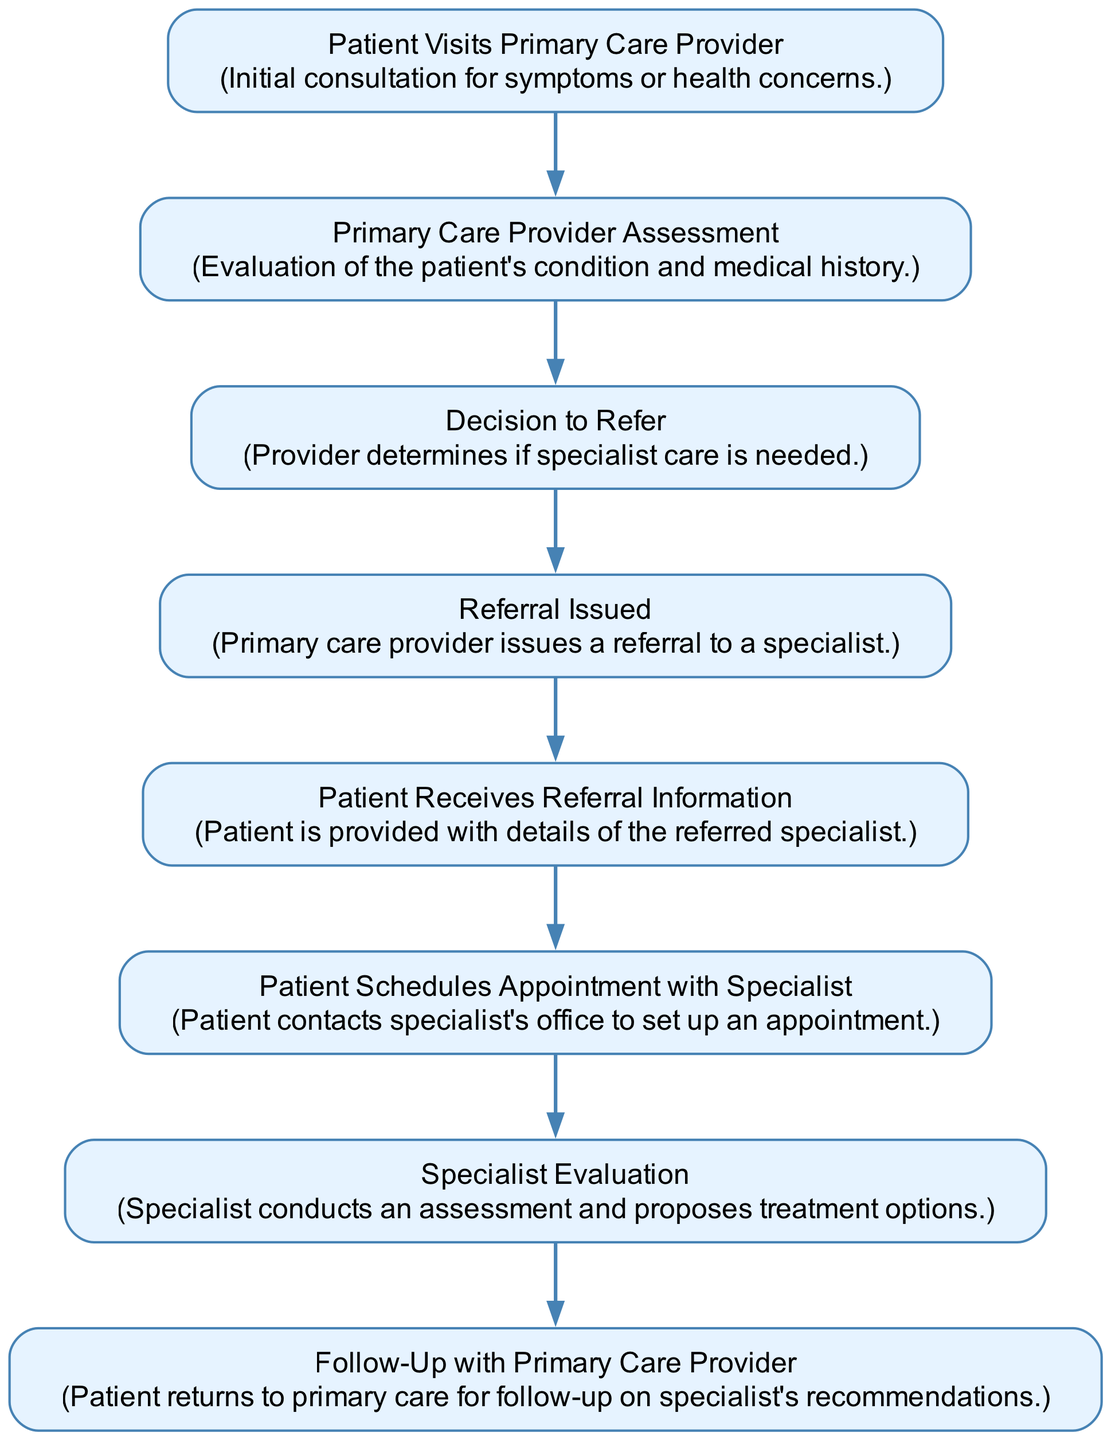What is the first step in the referral process? The first step, as indicated in the diagram, is "Patient Visits Primary Care Provider." This is the initial action taken in the referral process.
Answer: Patient Visits Primary Care Provider How many total steps are in the referral process? By counting each unique element in the diagram, we find there are eight distinct steps in the referral process. This includes every node from the patient's visit to the follow-up.
Answer: 8 What is the step that follows "Referral Issued"? The step that follows "Referral Issued" is "Patient Receives Referral Information." This is connected directly in the flow, showing the next action taken after the referral is issued.
Answer: Patient Receives Referral Information Which step requires the patient to contact the specialist's office? The step where the patient contacts the specialist's office is "Patient Schedules Appointment with Specialist." This indicates that the patient is actively taking action to arrange the appointment.
Answer: Patient Schedules Appointment with Specialist What is the last step in the referral process? The last step in the referral process is "Follow-Up with Primary Care Provider." This indicates that after the specialist's assessment, the patient goes back to the primary care provider for follow-up.
Answer: Follow-Up with Primary Care Provider What happens after "Specialist Evaluation"? After "Specialist Evaluation," the next step is "Follow-Up with Primary Care Provider." This shows the structure of the process where the outcomes of the specialist's evaluation lead back to the primary care provider.
Answer: Follow-Up with Primary Care Provider Which step involves assessment and treatment options? The step involving assessment and treatment options is "Specialist Evaluation." This indicates that during this step, the specialist evaluates the patient's condition and discusses potential treatments.
Answer: Specialist Evaluation Is "Decision to Refer" directly connected to "Patient Schedules Appointment with Specialist"? No, "Decision to Refer" is not directly connected to "Patient Schedules Appointment with Specialist." The flow indicates that the referral must be issued first before the patient can schedule an appointment.
Answer: No 